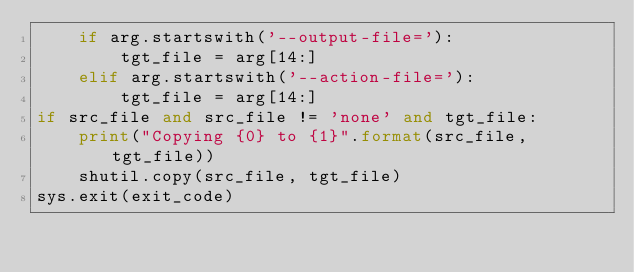<code> <loc_0><loc_0><loc_500><loc_500><_Python_>    if arg.startswith('--output-file='):
        tgt_file = arg[14:]
    elif arg.startswith('--action-file='):
        tgt_file = arg[14:]
if src_file and src_file != 'none' and tgt_file:
    print("Copying {0} to {1}".format(src_file, tgt_file))
    shutil.copy(src_file, tgt_file)
sys.exit(exit_code)
</code> 